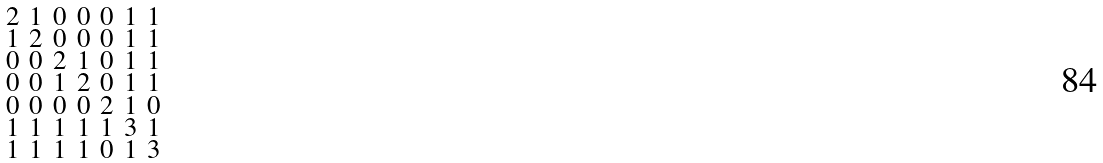Convert formula to latex. <formula><loc_0><loc_0><loc_500><loc_500>\begin{smallmatrix} 2 & 1 & 0 & 0 & 0 & 1 & 1 \\ 1 & 2 & 0 & 0 & 0 & 1 & 1 \\ 0 & 0 & 2 & 1 & 0 & 1 & 1 \\ 0 & 0 & 1 & 2 & 0 & 1 & 1 \\ 0 & 0 & 0 & 0 & 2 & 1 & 0 \\ 1 & 1 & 1 & 1 & 1 & 3 & 1 \\ 1 & 1 & 1 & 1 & 0 & 1 & 3 \end{smallmatrix}</formula> 